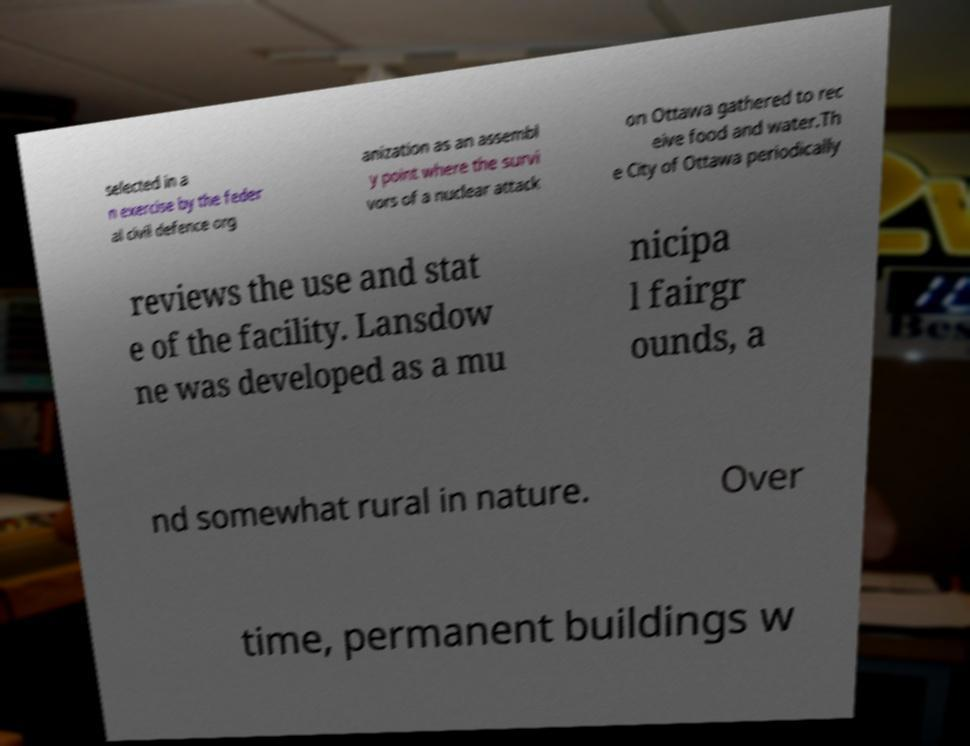I need the written content from this picture converted into text. Can you do that? selected in a n exercise by the feder al civil defence org anization as an assembl y point where the survi vors of a nuclear attack on Ottawa gathered to rec eive food and water.Th e City of Ottawa periodically reviews the use and stat e of the facility. Lansdow ne was developed as a mu nicipa l fairgr ounds, a nd somewhat rural in nature. Over time, permanent buildings w 